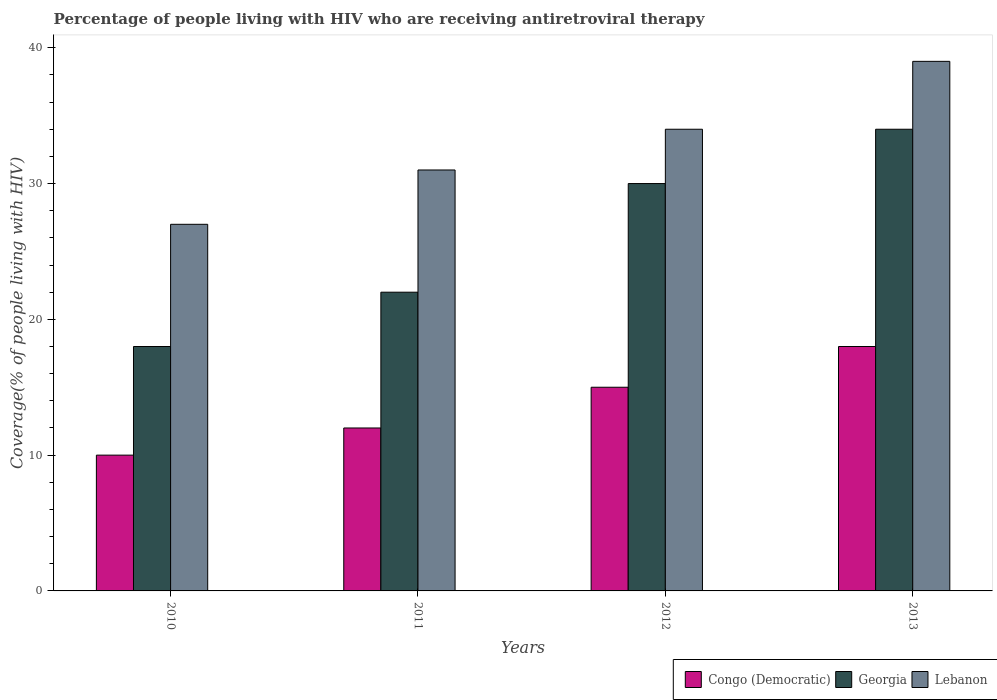Are the number of bars per tick equal to the number of legend labels?
Make the answer very short. Yes. Are the number of bars on each tick of the X-axis equal?
Give a very brief answer. Yes. How many bars are there on the 1st tick from the left?
Ensure brevity in your answer.  3. How many bars are there on the 2nd tick from the right?
Your answer should be compact. 3. In how many cases, is the number of bars for a given year not equal to the number of legend labels?
Provide a short and direct response. 0. What is the percentage of the HIV infected people who are receiving antiretroviral therapy in Lebanon in 2011?
Offer a very short reply. 31. Across all years, what is the maximum percentage of the HIV infected people who are receiving antiretroviral therapy in Congo (Democratic)?
Keep it short and to the point. 18. Across all years, what is the minimum percentage of the HIV infected people who are receiving antiretroviral therapy in Lebanon?
Make the answer very short. 27. In which year was the percentage of the HIV infected people who are receiving antiretroviral therapy in Georgia maximum?
Your response must be concise. 2013. What is the total percentage of the HIV infected people who are receiving antiretroviral therapy in Congo (Democratic) in the graph?
Make the answer very short. 55. What is the difference between the percentage of the HIV infected people who are receiving antiretroviral therapy in Congo (Democratic) in 2010 and that in 2011?
Ensure brevity in your answer.  -2. What is the difference between the percentage of the HIV infected people who are receiving antiretroviral therapy in Georgia in 2010 and the percentage of the HIV infected people who are receiving antiretroviral therapy in Congo (Democratic) in 2012?
Your response must be concise. 3. What is the average percentage of the HIV infected people who are receiving antiretroviral therapy in Lebanon per year?
Offer a terse response. 32.75. In the year 2011, what is the difference between the percentage of the HIV infected people who are receiving antiretroviral therapy in Lebanon and percentage of the HIV infected people who are receiving antiretroviral therapy in Georgia?
Offer a terse response. 9. In how many years, is the percentage of the HIV infected people who are receiving antiretroviral therapy in Congo (Democratic) greater than 8 %?
Provide a succinct answer. 4. What is the ratio of the percentage of the HIV infected people who are receiving antiretroviral therapy in Georgia in 2010 to that in 2012?
Your answer should be very brief. 0.6. Is the percentage of the HIV infected people who are receiving antiretroviral therapy in Lebanon in 2011 less than that in 2012?
Offer a very short reply. Yes. Is the difference between the percentage of the HIV infected people who are receiving antiretroviral therapy in Lebanon in 2012 and 2013 greater than the difference between the percentage of the HIV infected people who are receiving antiretroviral therapy in Georgia in 2012 and 2013?
Make the answer very short. No. What is the difference between the highest and the lowest percentage of the HIV infected people who are receiving antiretroviral therapy in Georgia?
Offer a very short reply. 16. Is the sum of the percentage of the HIV infected people who are receiving antiretroviral therapy in Lebanon in 2011 and 2012 greater than the maximum percentage of the HIV infected people who are receiving antiretroviral therapy in Congo (Democratic) across all years?
Ensure brevity in your answer.  Yes. What does the 3rd bar from the left in 2013 represents?
Keep it short and to the point. Lebanon. What does the 2nd bar from the right in 2012 represents?
Ensure brevity in your answer.  Georgia. How many bars are there?
Give a very brief answer. 12. Are all the bars in the graph horizontal?
Give a very brief answer. No. Are the values on the major ticks of Y-axis written in scientific E-notation?
Your response must be concise. No. Does the graph contain grids?
Your answer should be very brief. No. How many legend labels are there?
Give a very brief answer. 3. How are the legend labels stacked?
Keep it short and to the point. Horizontal. What is the title of the graph?
Keep it short and to the point. Percentage of people living with HIV who are receiving antiretroviral therapy. Does "Mozambique" appear as one of the legend labels in the graph?
Offer a terse response. No. What is the label or title of the Y-axis?
Ensure brevity in your answer.  Coverage(% of people living with HIV). What is the Coverage(% of people living with HIV) in Congo (Democratic) in 2010?
Your answer should be compact. 10. What is the Coverage(% of people living with HIV) of Georgia in 2010?
Your answer should be compact. 18. What is the Coverage(% of people living with HIV) of Congo (Democratic) in 2011?
Keep it short and to the point. 12. What is the Coverage(% of people living with HIV) in Lebanon in 2011?
Ensure brevity in your answer.  31. What is the Coverage(% of people living with HIV) of Congo (Democratic) in 2012?
Keep it short and to the point. 15. What is the Coverage(% of people living with HIV) in Georgia in 2013?
Offer a very short reply. 34. Across all years, what is the maximum Coverage(% of people living with HIV) in Lebanon?
Provide a succinct answer. 39. Across all years, what is the minimum Coverage(% of people living with HIV) of Lebanon?
Make the answer very short. 27. What is the total Coverage(% of people living with HIV) of Georgia in the graph?
Provide a succinct answer. 104. What is the total Coverage(% of people living with HIV) of Lebanon in the graph?
Provide a short and direct response. 131. What is the difference between the Coverage(% of people living with HIV) of Congo (Democratic) in 2010 and that in 2012?
Offer a very short reply. -5. What is the difference between the Coverage(% of people living with HIV) in Lebanon in 2010 and that in 2012?
Your response must be concise. -7. What is the difference between the Coverage(% of people living with HIV) in Georgia in 2010 and that in 2013?
Make the answer very short. -16. What is the difference between the Coverage(% of people living with HIV) in Congo (Democratic) in 2011 and that in 2012?
Keep it short and to the point. -3. What is the difference between the Coverage(% of people living with HIV) of Lebanon in 2011 and that in 2012?
Provide a succinct answer. -3. What is the difference between the Coverage(% of people living with HIV) of Lebanon in 2011 and that in 2013?
Provide a succinct answer. -8. What is the difference between the Coverage(% of people living with HIV) of Congo (Democratic) in 2012 and that in 2013?
Your answer should be very brief. -3. What is the difference between the Coverage(% of people living with HIV) in Lebanon in 2012 and that in 2013?
Your answer should be very brief. -5. What is the difference between the Coverage(% of people living with HIV) in Georgia in 2010 and the Coverage(% of people living with HIV) in Lebanon in 2011?
Your response must be concise. -13. What is the difference between the Coverage(% of people living with HIV) of Congo (Democratic) in 2010 and the Coverage(% of people living with HIV) of Georgia in 2012?
Provide a succinct answer. -20. What is the difference between the Coverage(% of people living with HIV) of Congo (Democratic) in 2010 and the Coverage(% of people living with HIV) of Lebanon in 2012?
Make the answer very short. -24. What is the difference between the Coverage(% of people living with HIV) in Congo (Democratic) in 2011 and the Coverage(% of people living with HIV) in Georgia in 2012?
Offer a terse response. -18. What is the difference between the Coverage(% of people living with HIV) of Georgia in 2011 and the Coverage(% of people living with HIV) of Lebanon in 2012?
Your answer should be compact. -12. What is the difference between the Coverage(% of people living with HIV) of Congo (Democratic) in 2011 and the Coverage(% of people living with HIV) of Georgia in 2013?
Your answer should be compact. -22. What is the average Coverage(% of people living with HIV) of Congo (Democratic) per year?
Give a very brief answer. 13.75. What is the average Coverage(% of people living with HIV) of Georgia per year?
Give a very brief answer. 26. What is the average Coverage(% of people living with HIV) of Lebanon per year?
Your response must be concise. 32.75. In the year 2010, what is the difference between the Coverage(% of people living with HIV) of Congo (Democratic) and Coverage(% of people living with HIV) of Georgia?
Give a very brief answer. -8. In the year 2010, what is the difference between the Coverage(% of people living with HIV) of Georgia and Coverage(% of people living with HIV) of Lebanon?
Give a very brief answer. -9. In the year 2011, what is the difference between the Coverage(% of people living with HIV) of Congo (Democratic) and Coverage(% of people living with HIV) of Georgia?
Your response must be concise. -10. In the year 2011, what is the difference between the Coverage(% of people living with HIV) of Georgia and Coverage(% of people living with HIV) of Lebanon?
Provide a short and direct response. -9. In the year 2012, what is the difference between the Coverage(% of people living with HIV) in Congo (Democratic) and Coverage(% of people living with HIV) in Lebanon?
Offer a terse response. -19. In the year 2013, what is the difference between the Coverage(% of people living with HIV) of Congo (Democratic) and Coverage(% of people living with HIV) of Georgia?
Keep it short and to the point. -16. In the year 2013, what is the difference between the Coverage(% of people living with HIV) in Georgia and Coverage(% of people living with HIV) in Lebanon?
Keep it short and to the point. -5. What is the ratio of the Coverage(% of people living with HIV) of Georgia in 2010 to that in 2011?
Provide a succinct answer. 0.82. What is the ratio of the Coverage(% of people living with HIV) in Lebanon in 2010 to that in 2011?
Your answer should be very brief. 0.87. What is the ratio of the Coverage(% of people living with HIV) of Georgia in 2010 to that in 2012?
Your answer should be very brief. 0.6. What is the ratio of the Coverage(% of people living with HIV) of Lebanon in 2010 to that in 2012?
Keep it short and to the point. 0.79. What is the ratio of the Coverage(% of people living with HIV) of Congo (Democratic) in 2010 to that in 2013?
Provide a succinct answer. 0.56. What is the ratio of the Coverage(% of people living with HIV) in Georgia in 2010 to that in 2013?
Keep it short and to the point. 0.53. What is the ratio of the Coverage(% of people living with HIV) in Lebanon in 2010 to that in 2013?
Offer a terse response. 0.69. What is the ratio of the Coverage(% of people living with HIV) in Congo (Democratic) in 2011 to that in 2012?
Your answer should be compact. 0.8. What is the ratio of the Coverage(% of people living with HIV) of Georgia in 2011 to that in 2012?
Make the answer very short. 0.73. What is the ratio of the Coverage(% of people living with HIV) of Lebanon in 2011 to that in 2012?
Give a very brief answer. 0.91. What is the ratio of the Coverage(% of people living with HIV) in Congo (Democratic) in 2011 to that in 2013?
Your answer should be very brief. 0.67. What is the ratio of the Coverage(% of people living with HIV) of Georgia in 2011 to that in 2013?
Provide a short and direct response. 0.65. What is the ratio of the Coverage(% of people living with HIV) in Lebanon in 2011 to that in 2013?
Offer a terse response. 0.79. What is the ratio of the Coverage(% of people living with HIV) of Georgia in 2012 to that in 2013?
Ensure brevity in your answer.  0.88. What is the ratio of the Coverage(% of people living with HIV) of Lebanon in 2012 to that in 2013?
Your response must be concise. 0.87. What is the difference between the highest and the second highest Coverage(% of people living with HIV) of Georgia?
Your response must be concise. 4. What is the difference between the highest and the second highest Coverage(% of people living with HIV) of Lebanon?
Offer a very short reply. 5. What is the difference between the highest and the lowest Coverage(% of people living with HIV) of Congo (Democratic)?
Give a very brief answer. 8. What is the difference between the highest and the lowest Coverage(% of people living with HIV) of Georgia?
Offer a terse response. 16. What is the difference between the highest and the lowest Coverage(% of people living with HIV) in Lebanon?
Your response must be concise. 12. 